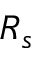<formula> <loc_0><loc_0><loc_500><loc_500>R _ { s }</formula> 